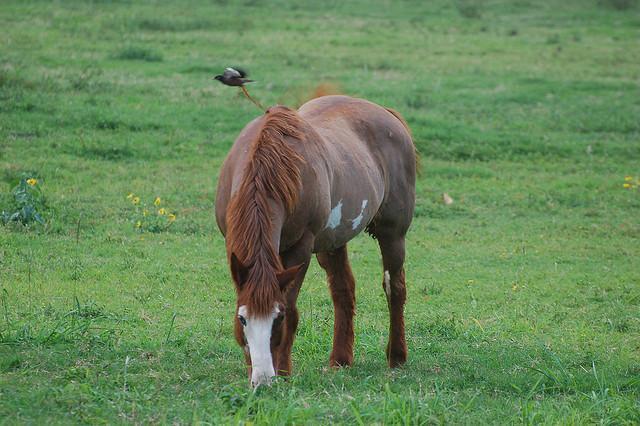How many train cars are painted black?
Give a very brief answer. 0. 